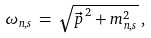Convert formula to latex. <formula><loc_0><loc_0><loc_500><loc_500>\omega _ { n , s } \, = \, \sqrt { { \vec { p } \, } ^ { 2 } + m _ { n , s } ^ { 2 } } \, ,</formula> 